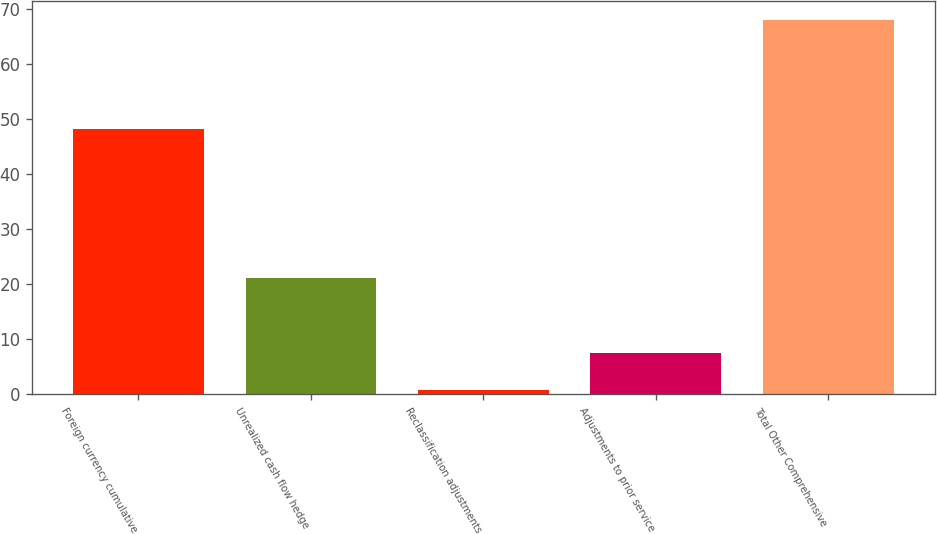Convert chart to OTSL. <chart><loc_0><loc_0><loc_500><loc_500><bar_chart><fcel>Foreign currency cumulative<fcel>Unrealized cash flow hedge<fcel>Reclassification adjustments<fcel>Adjustments to prior service<fcel>Total Other Comprehensive<nl><fcel>48.2<fcel>21<fcel>0.8<fcel>7.52<fcel>68<nl></chart> 